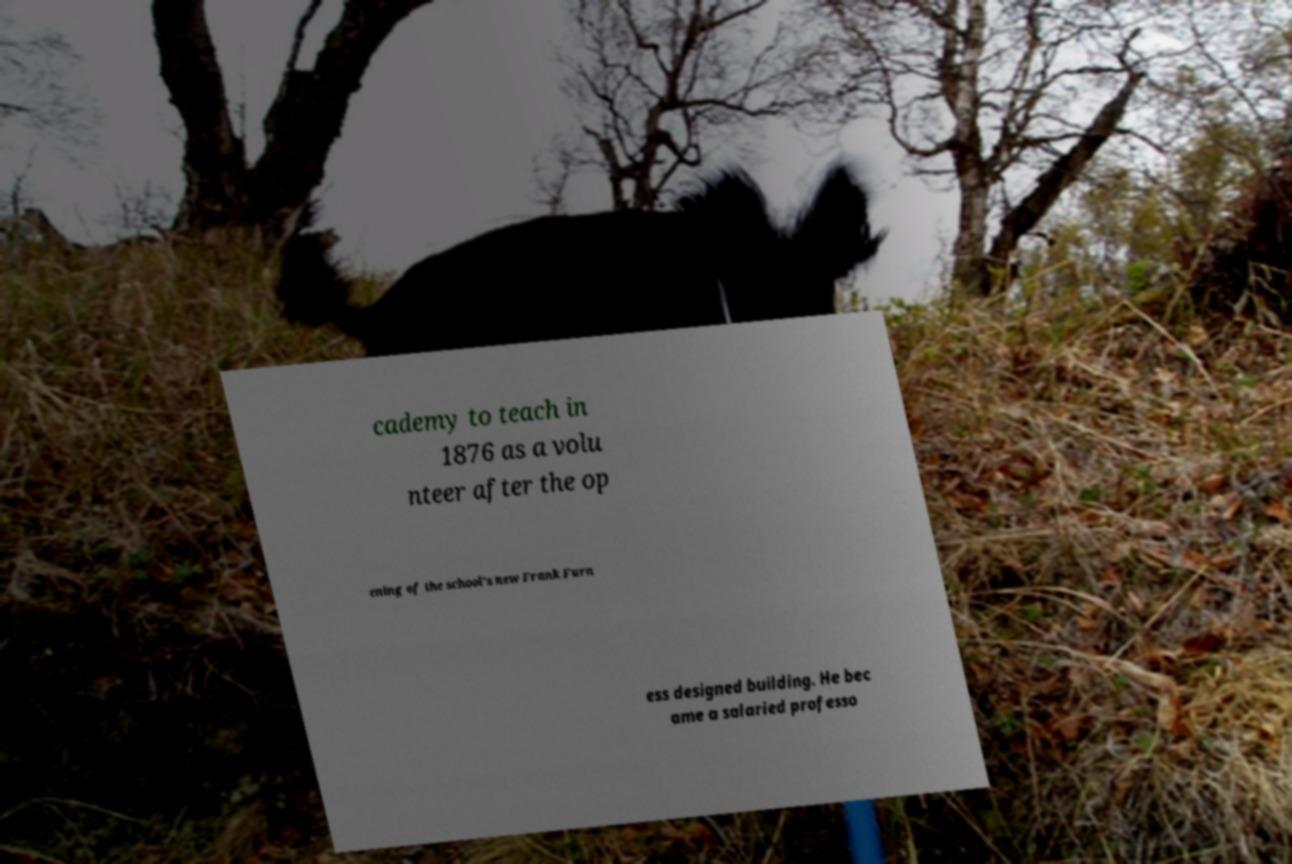Can you read and provide the text displayed in the image?This photo seems to have some interesting text. Can you extract and type it out for me? cademy to teach in 1876 as a volu nteer after the op ening of the school's new Frank Furn ess designed building. He bec ame a salaried professo 